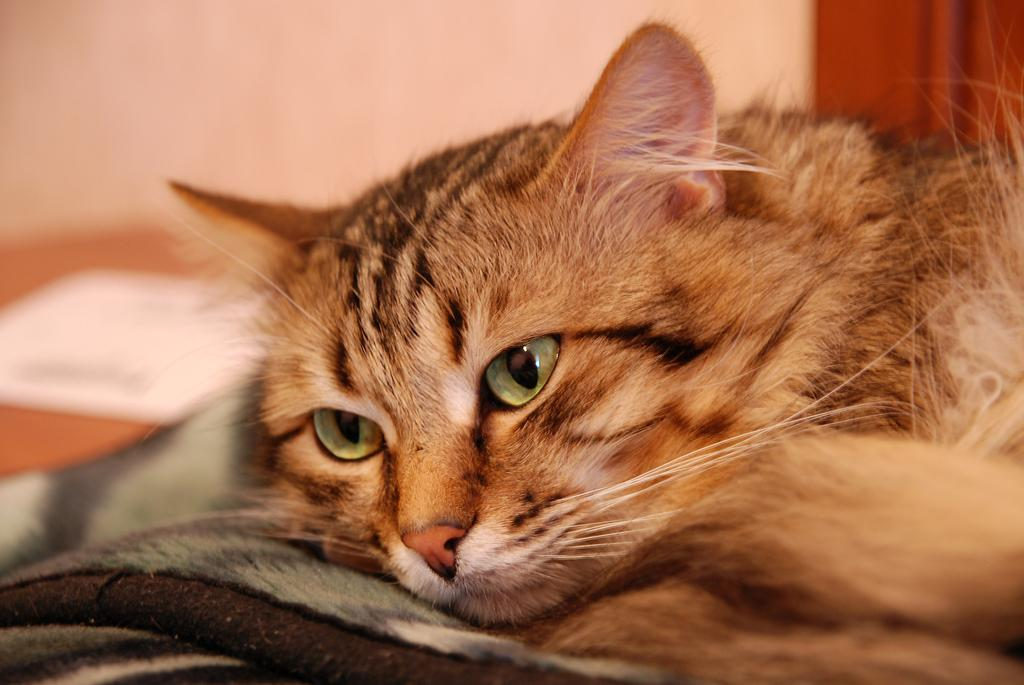What animal can be seen in the image? There is a cat laying on a bed sheet in the image. What color is the object on the left side of the image? The object on the left side of the image is white. What type of structure is visible in the background of the image? There is a wall in the background of the image. What color is the curtain in the background of the image? The curtain in the background of the image is red. How many clocks are visible on the wall in the image? There are no clocks visible on the wall in the image. What type of truck can be seen driving through the room in the image? There is no truck present in the image; it is a room with a cat, a white object, a wall, and a red curtain. 